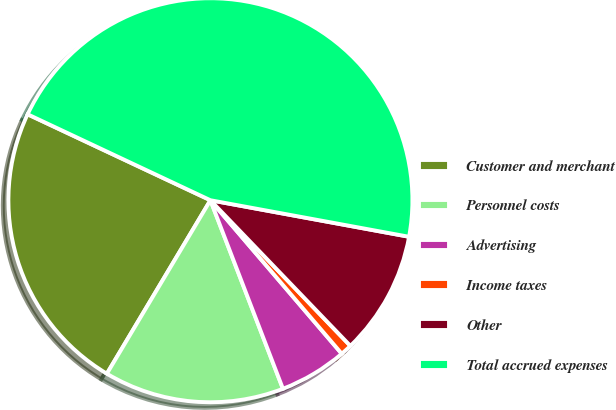<chart> <loc_0><loc_0><loc_500><loc_500><pie_chart><fcel>Customer and merchant<fcel>Personnel costs<fcel>Advertising<fcel>Income taxes<fcel>Other<fcel>Total accrued expenses<nl><fcel>23.43%<fcel>14.41%<fcel>5.42%<fcel>0.92%<fcel>9.92%<fcel>45.9%<nl></chart> 